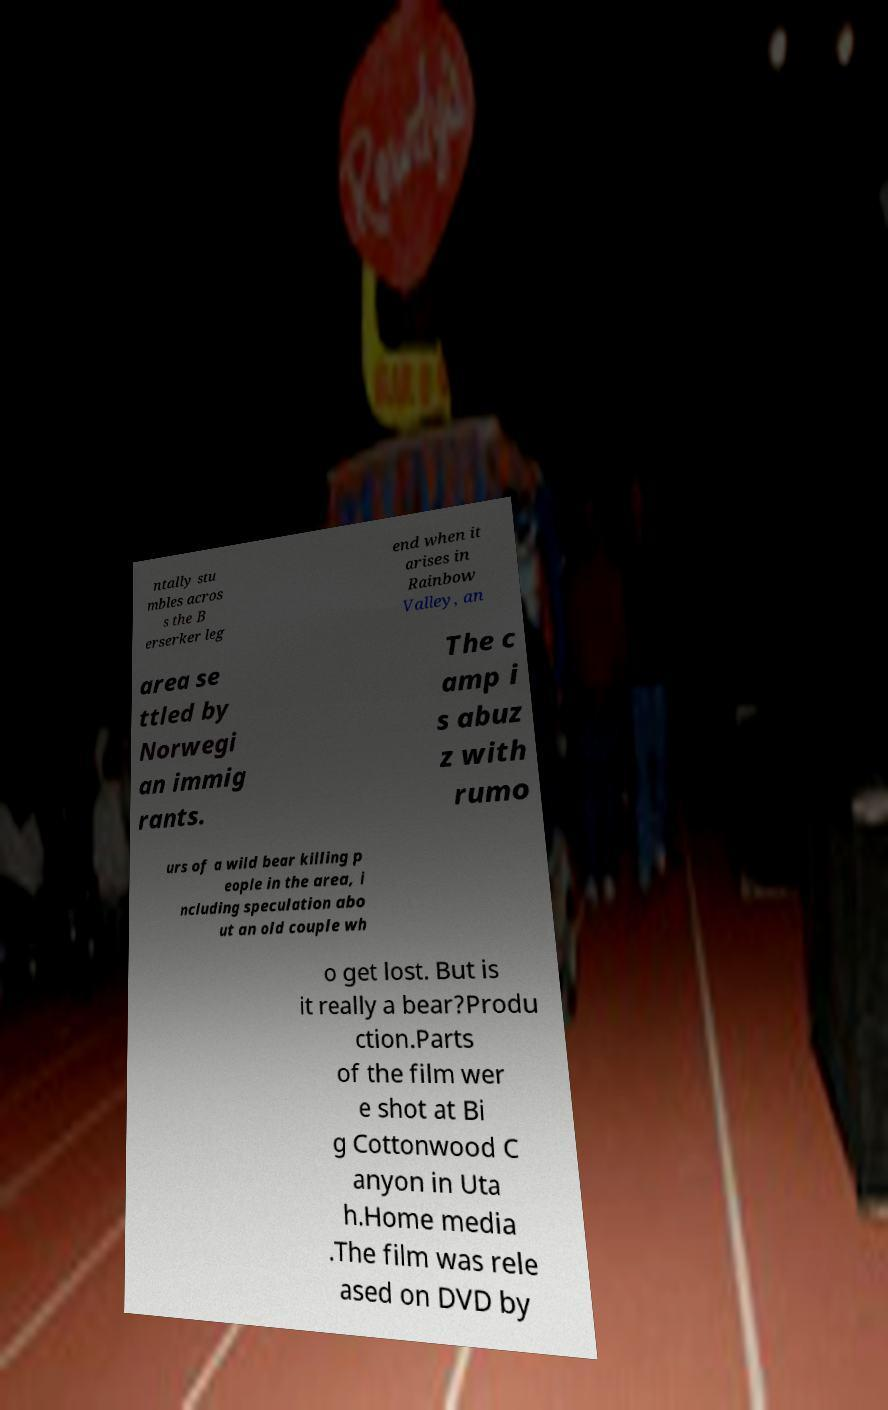For documentation purposes, I need the text within this image transcribed. Could you provide that? ntally stu mbles acros s the B erserker leg end when it arises in Rainbow Valley, an area se ttled by Norwegi an immig rants. The c amp i s abuz z with rumo urs of a wild bear killing p eople in the area, i ncluding speculation abo ut an old couple wh o get lost. But is it really a bear?Produ ction.Parts of the film wer e shot at Bi g Cottonwood C anyon in Uta h.Home media .The film was rele ased on DVD by 